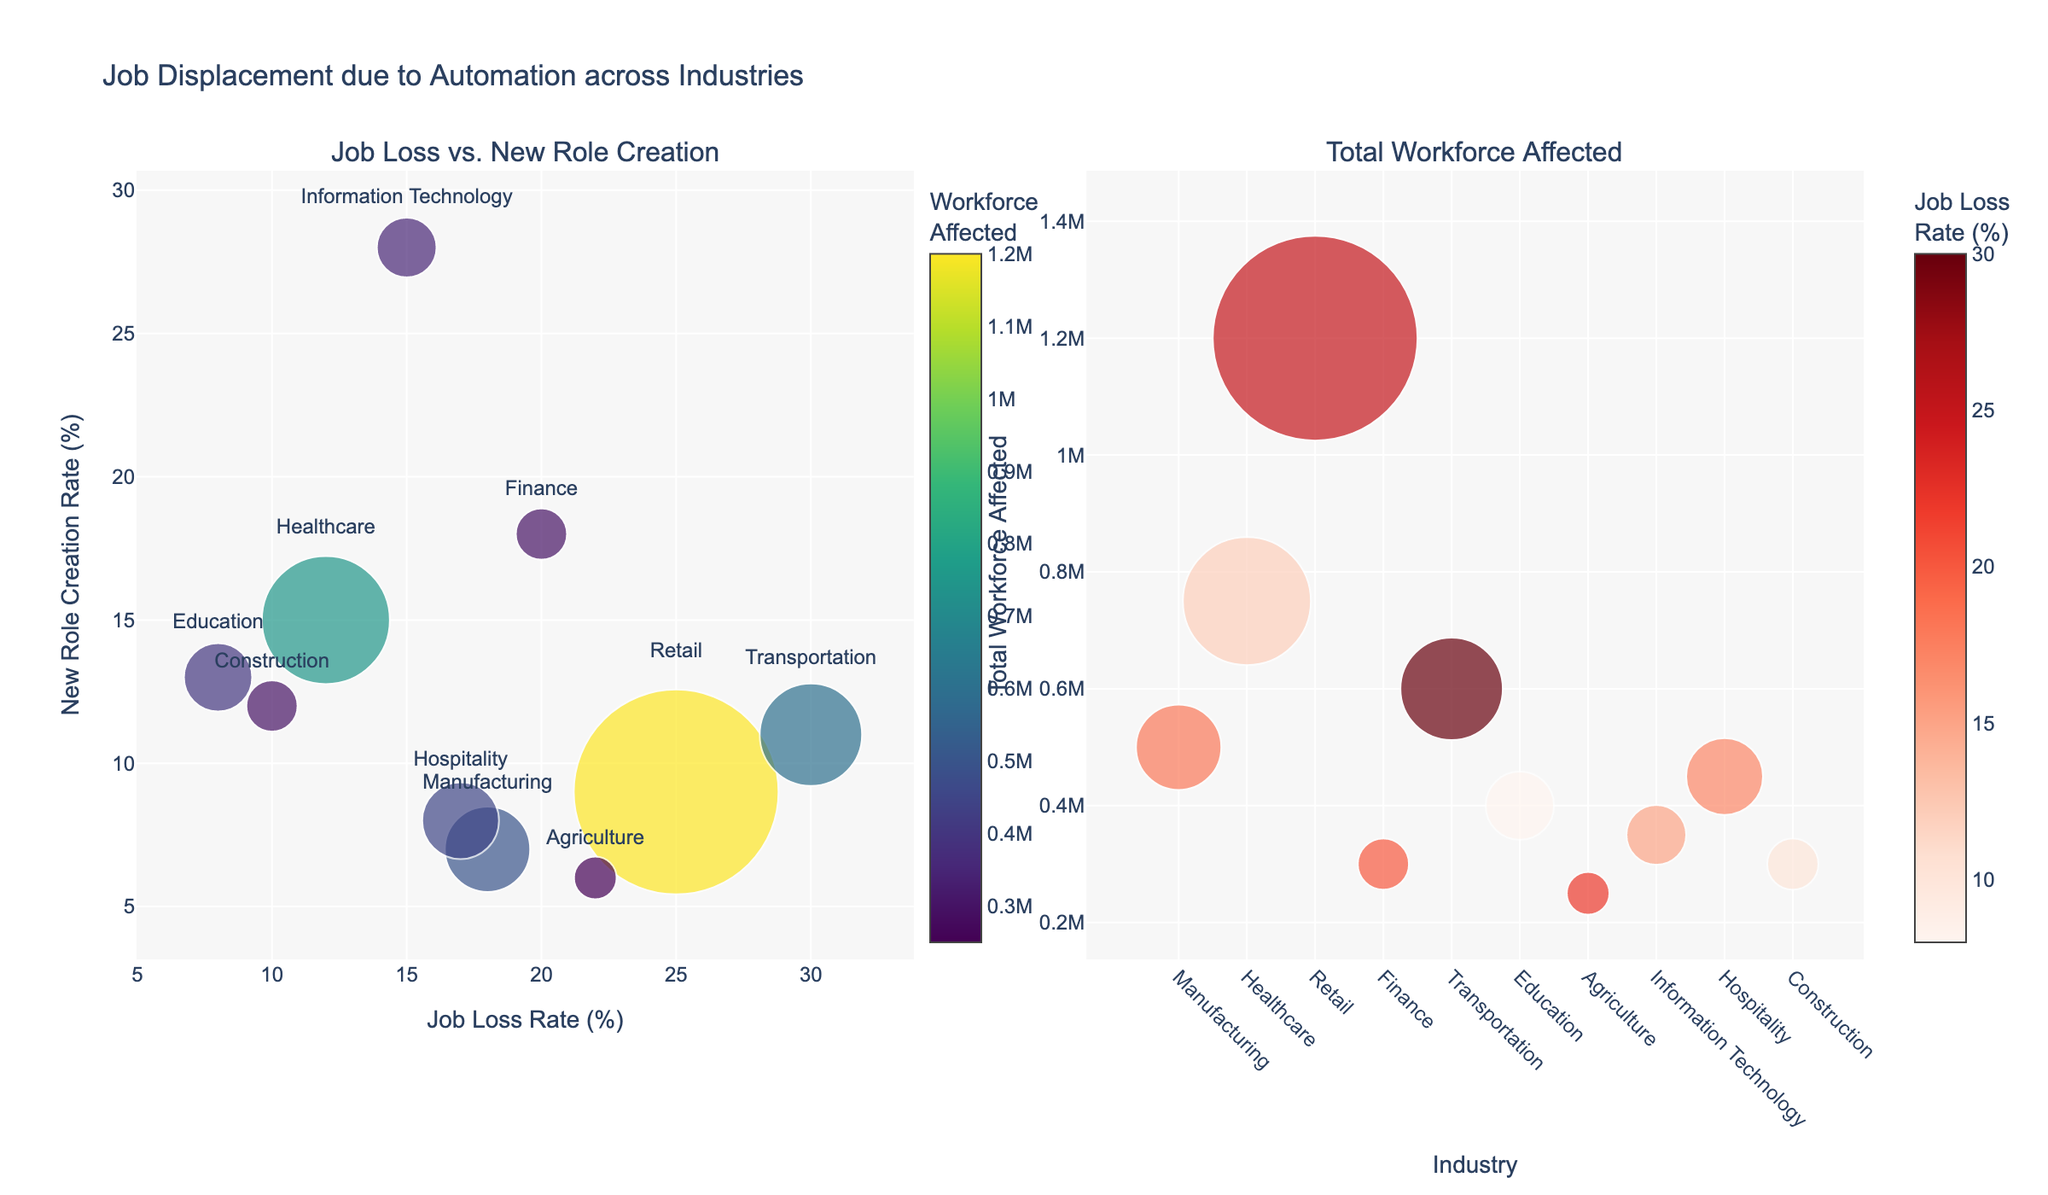Which industry has the highest job loss rate? From the subplot on the left, locate the point with the highest x-coordinate as it represents the job loss rate. The transportation industry has the highest job loss rate at 30%.
Answer: Transportation Which industry has the highest new role creation rate? From the subplot on the left, locate the point with the highest y-coordinate as it represents the new role creation rate. The information technology industry has the highest new role creation rate at 28%.
Answer: Information Technology What industry affects the largest total workforce? From the subplot on the right, identify the point with the largest marker size, as marker size represents the total workforce affected. The retail industry has the largest total workforce affected with 1,200,000 people.
Answer: Retail Which industry has the smallest job loss rate? From the subplot on the left, identify the point with the smallest x-coordinate as it represents the smallest job loss rate. The education industry has the smallest job loss rate at 8%.
Answer: Education Compare the job loss and new role creation rates of the finance industry. From the subplot on the left, locate the point labeled "Finance." Its x-coordinate (job loss rate) is 20% and its y-coordinate (new role creation rate) is 18%.
Answer: Job Loss: 20%, New Roles: 18% Which industry has a higher new role creation rate: Healthcare or Construction? From the subplot on the left, compare the y-coordinates of the points labeled "Healthcare" and "Construction." Healthcare's new role creation rate is 15%, while Construction's new role creation rate is 12%.
Answer: Healthcare Which industry has the lowest new role creation rate? From the subplot on the left, identify the point with the smallest y-coordinate, which represents the new role creation rate. The agriculture industry has the lowest new role creation rate at 6%.
Answer: Agriculture How many industries have a job loss rate greater than 20%? From the subplot on the left, count the number of points with x-coordinates greater than 20%. There are three such industries: Retail, Transportation, and Agriculture.
Answer: 3 Compare the transportation and information technology industries based on their workforce affected and job loss rate. From the subplot on the right, compare the marker sizes and colors. Transportation affects 600,000 people with a job loss rate of 30%. Information Technology affects 350,000 people with a job loss rate of 15%.
Answer: Transportation: 600,000, 30%; IT: 350,000, 15% Which industries are represented in the upper right quadrant of the "Job Loss vs. New Role Creation" subplot? From the subplot on the left, identify the points in the upper right quadrant where both job loss rate and new role creation rate are high. Finance (20%, 18%) and Information Technology (15%, 28%) fall into this quadrant.
Answer: Finance, Information Technology 